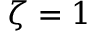<formula> <loc_0><loc_0><loc_500><loc_500>\zeta = 1</formula> 